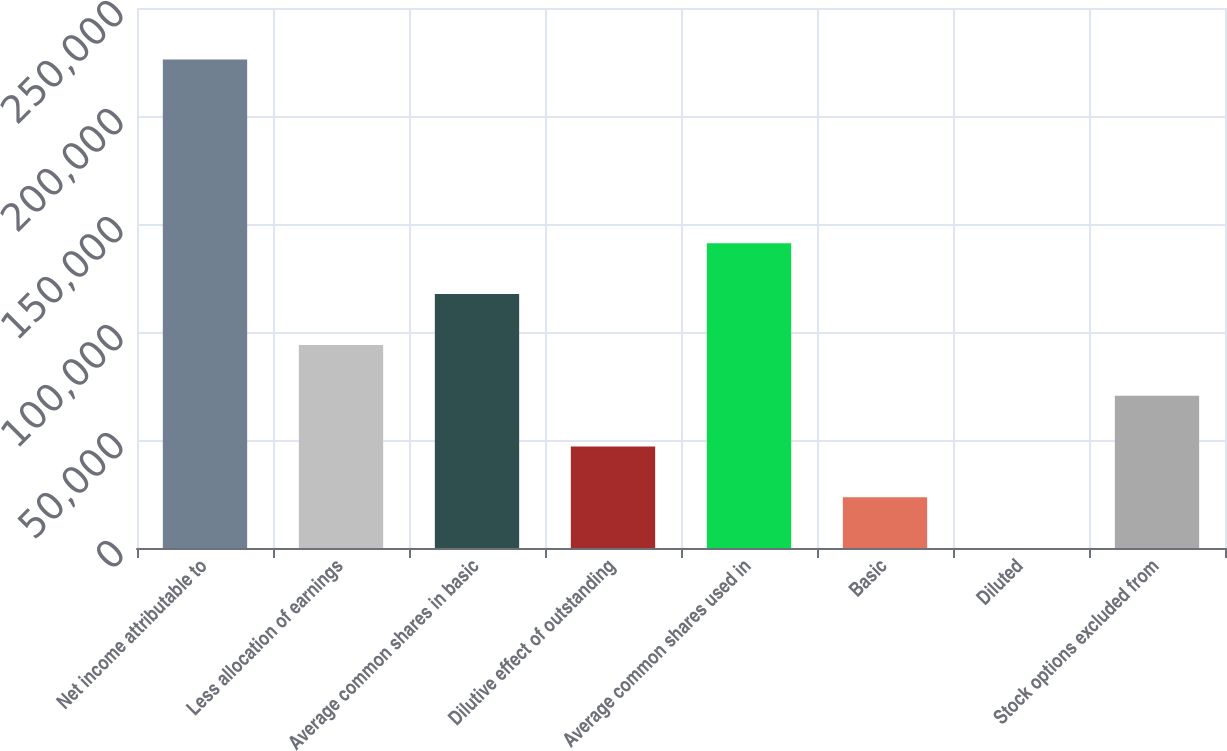Convert chart to OTSL. <chart><loc_0><loc_0><loc_500><loc_500><bar_chart><fcel>Net income attributable to<fcel>Less allocation of earnings<fcel>Average common shares in basic<fcel>Dilutive effect of outstanding<fcel>Average common shares used in<fcel>Basic<fcel>Diluted<fcel>Stock options excluded from<nl><fcel>226210<fcel>94032.4<fcel>117540<fcel>47017.2<fcel>141048<fcel>23509.5<fcel>1.93<fcel>70524.8<nl></chart> 